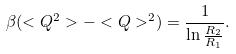<formula> <loc_0><loc_0><loc_500><loc_500>\beta ( < Q ^ { 2 } > - < Q > ^ { 2 } ) = \frac { 1 } { \ln \frac { R _ { 2 } } { R _ { 1 } } } .</formula> 